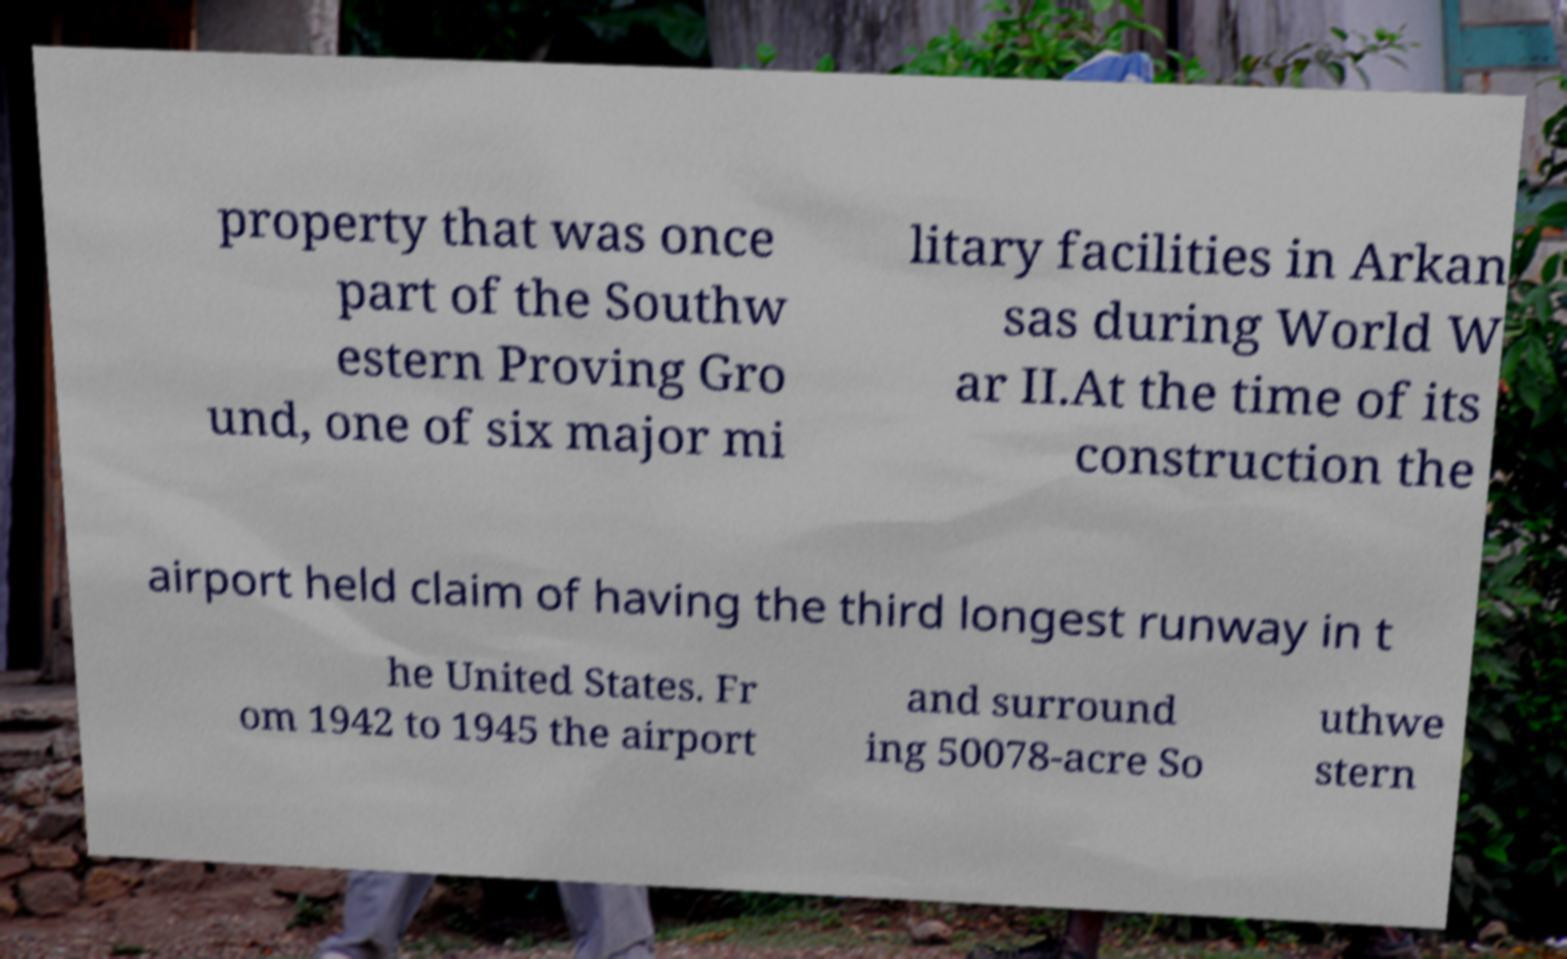There's text embedded in this image that I need extracted. Can you transcribe it verbatim? property that was once part of the Southw estern Proving Gro und, one of six major mi litary facilities in Arkan sas during World W ar II.At the time of its construction the airport held claim of having the third longest runway in t he United States. Fr om 1942 to 1945 the airport and surround ing 50078-acre So uthwe stern 